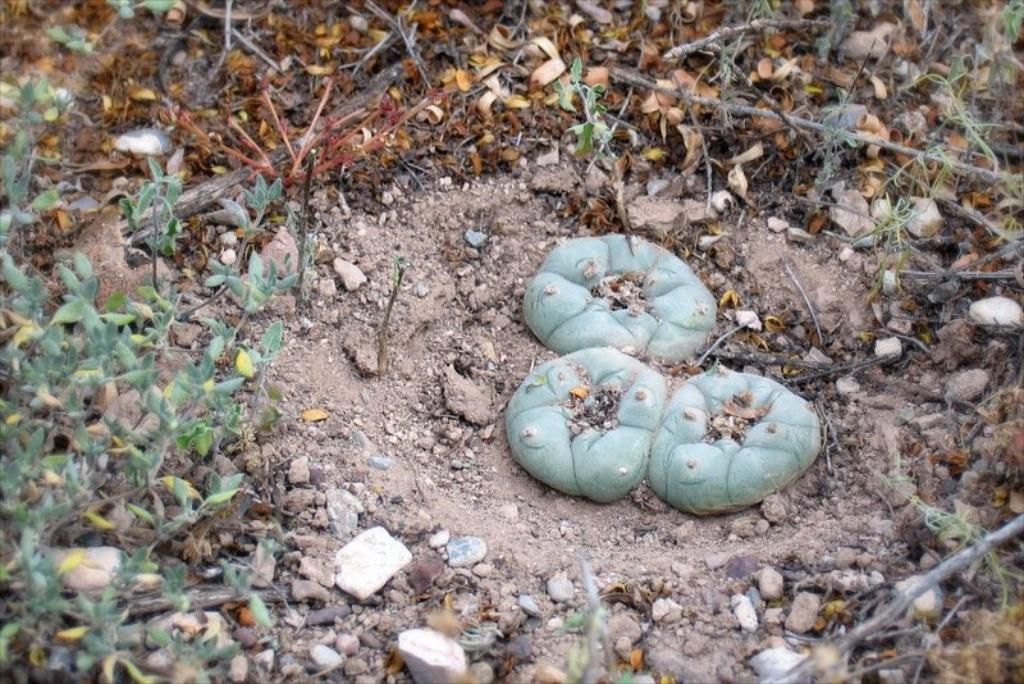What type of fruits are present in the image? There are three green winter squash fruits in the image. Where are the winter squash fruits located? The winter squash fruits are on the ground in the image. What else can be seen on the ground in the image? There are dry leaves and stones on the ground in the image. What type of ear is visible on one of the winter squash fruits in the image? There are no ears visible on the winter squash fruits in the image, as they are fruits and not animals. 